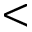Convert formula to latex. <formula><loc_0><loc_0><loc_500><loc_500><</formula> 